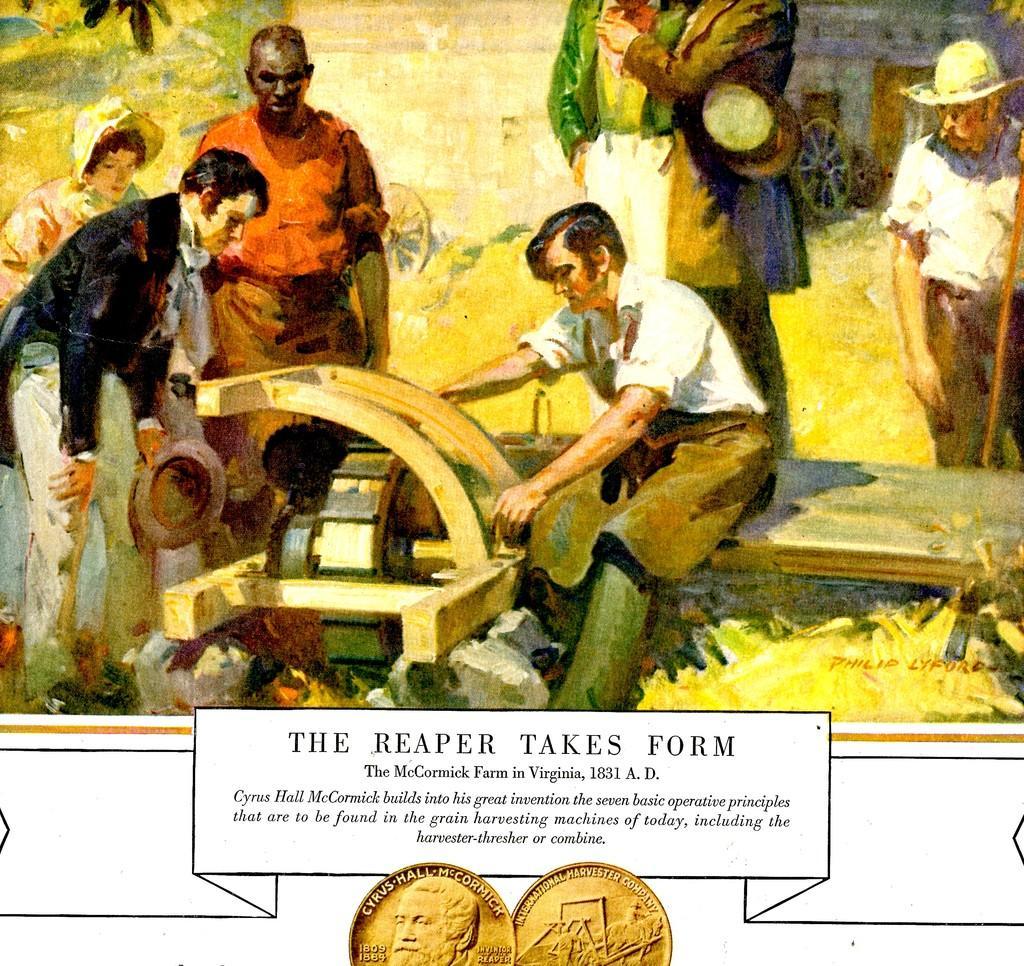How would you summarize this image in a sentence or two? This is an animated image, in this image in the center there is one person who is doing something. And in the background there are some people who are standing and at the bottom of the image there is some text written and two coins. 